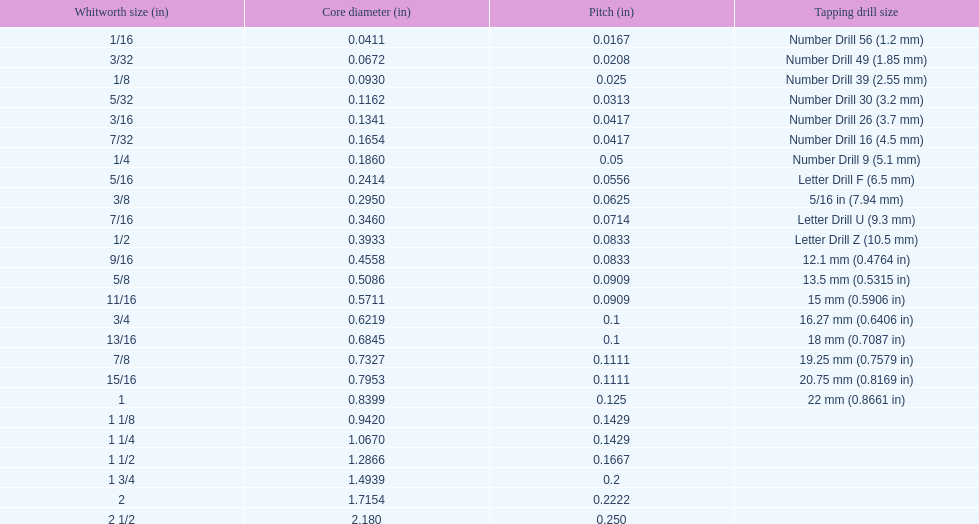Which whitworth size is the only one with 5 threads per inch? 1 3/4. 